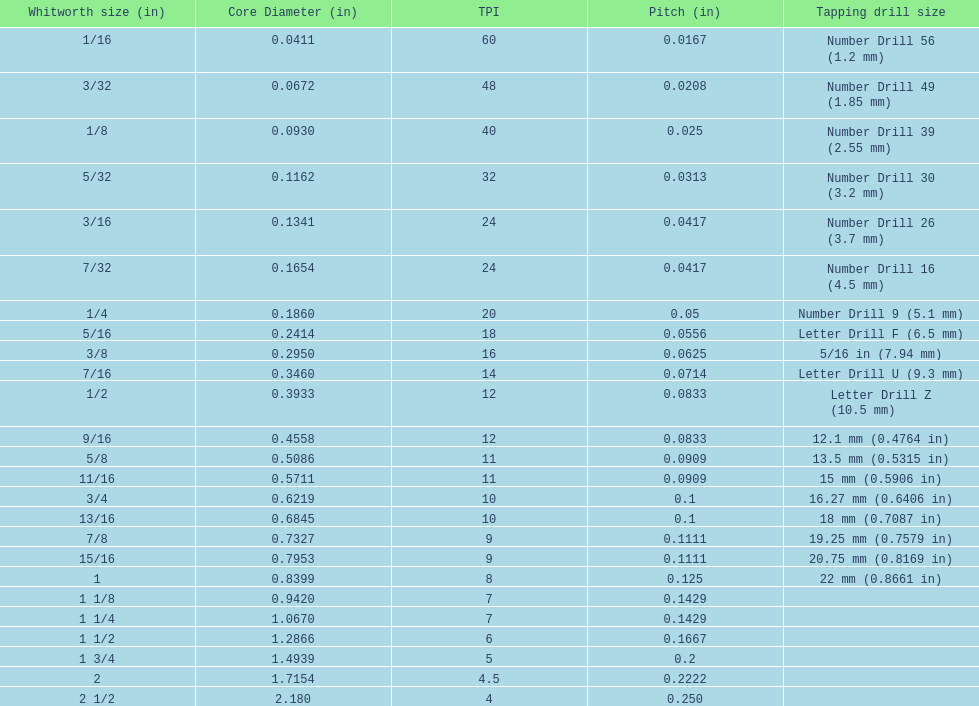What is the top amount of threads per inch? 60. 